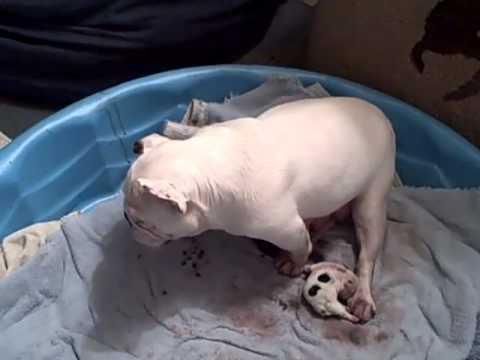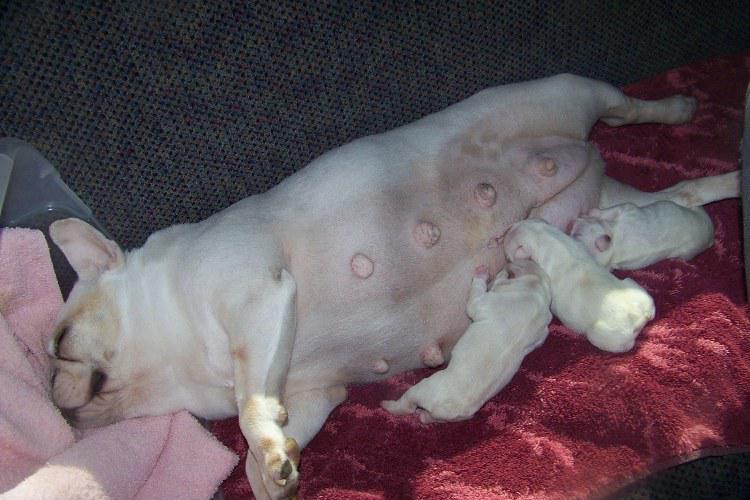The first image is the image on the left, the second image is the image on the right. Given the left and right images, does the statement "The right image contains an adult dog nursing her puppies." hold true? Answer yes or no. Yes. The first image is the image on the left, the second image is the image on the right. Evaluate the accuracy of this statement regarding the images: "A mother dog is laying on her side feeding at least 3 puppies.". Is it true? Answer yes or no. Yes. 